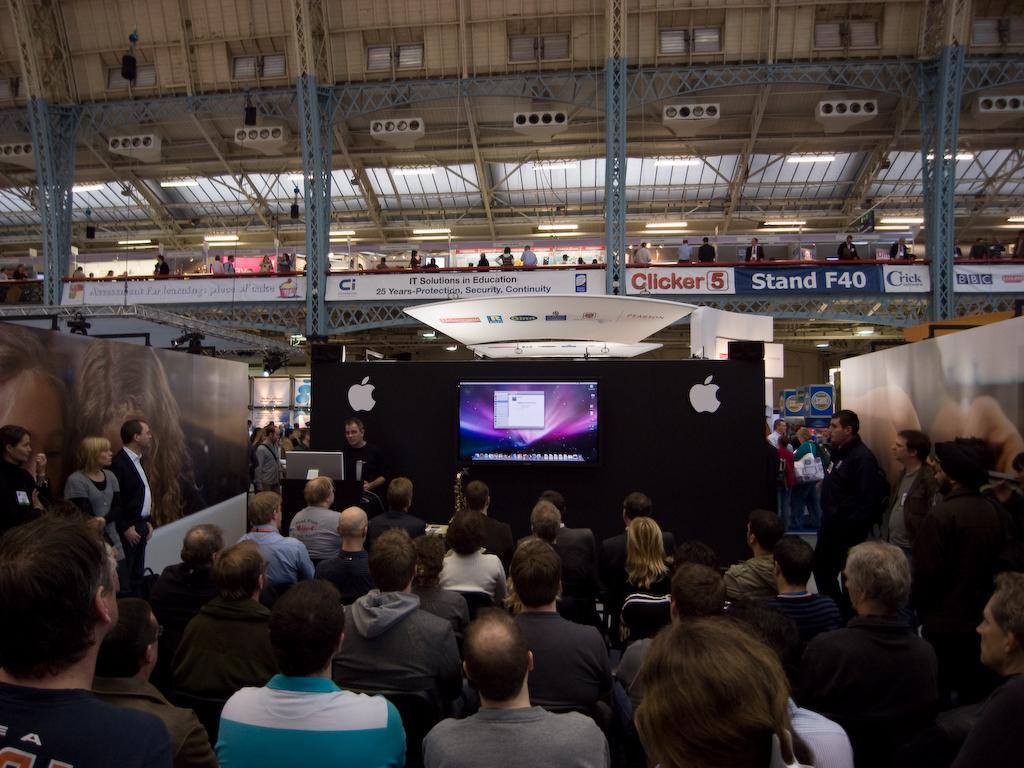Could you give a brief overview of what you see in this image? At the top of the image we can see iron grills, electric lights, person standing on the floor and advertisement boards. At the bottom of the image we can see people sitting on the chairs and standing on the floor and one of them is standing at the lectern. In the background we can see a display screen. 